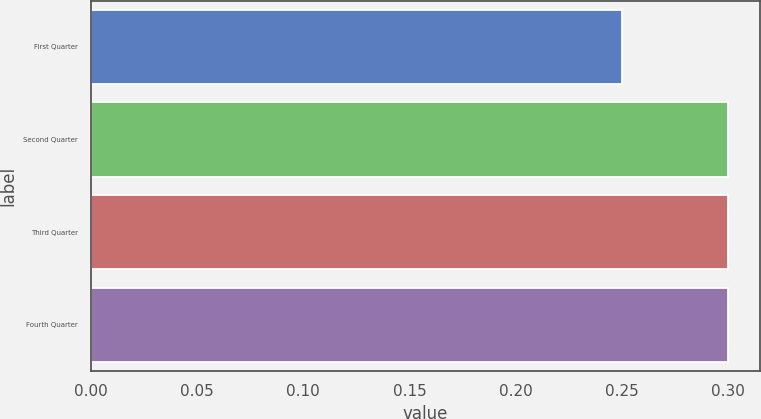<chart> <loc_0><loc_0><loc_500><loc_500><bar_chart><fcel>First Quarter<fcel>Second Quarter<fcel>Third Quarter<fcel>Fourth Quarter<nl><fcel>0.25<fcel>0.3<fcel>0.3<fcel>0.3<nl></chart> 